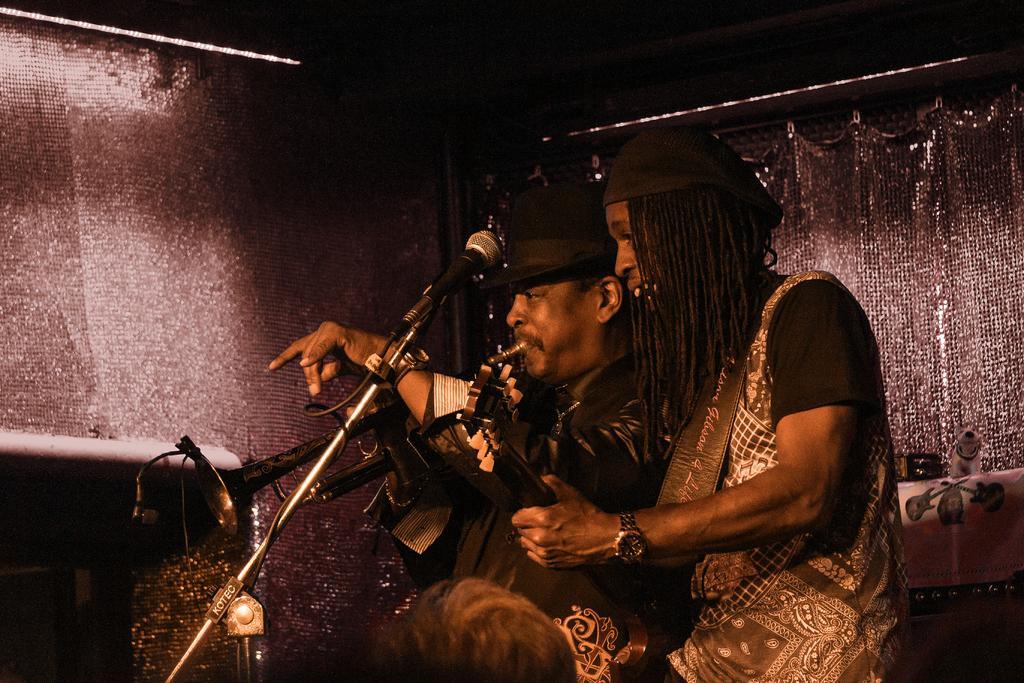Please provide a concise description of this image. In this image we can see this person is playing the guitar and this person is playing the trumpet and there is a mic to stand. The background of the image is dark. 